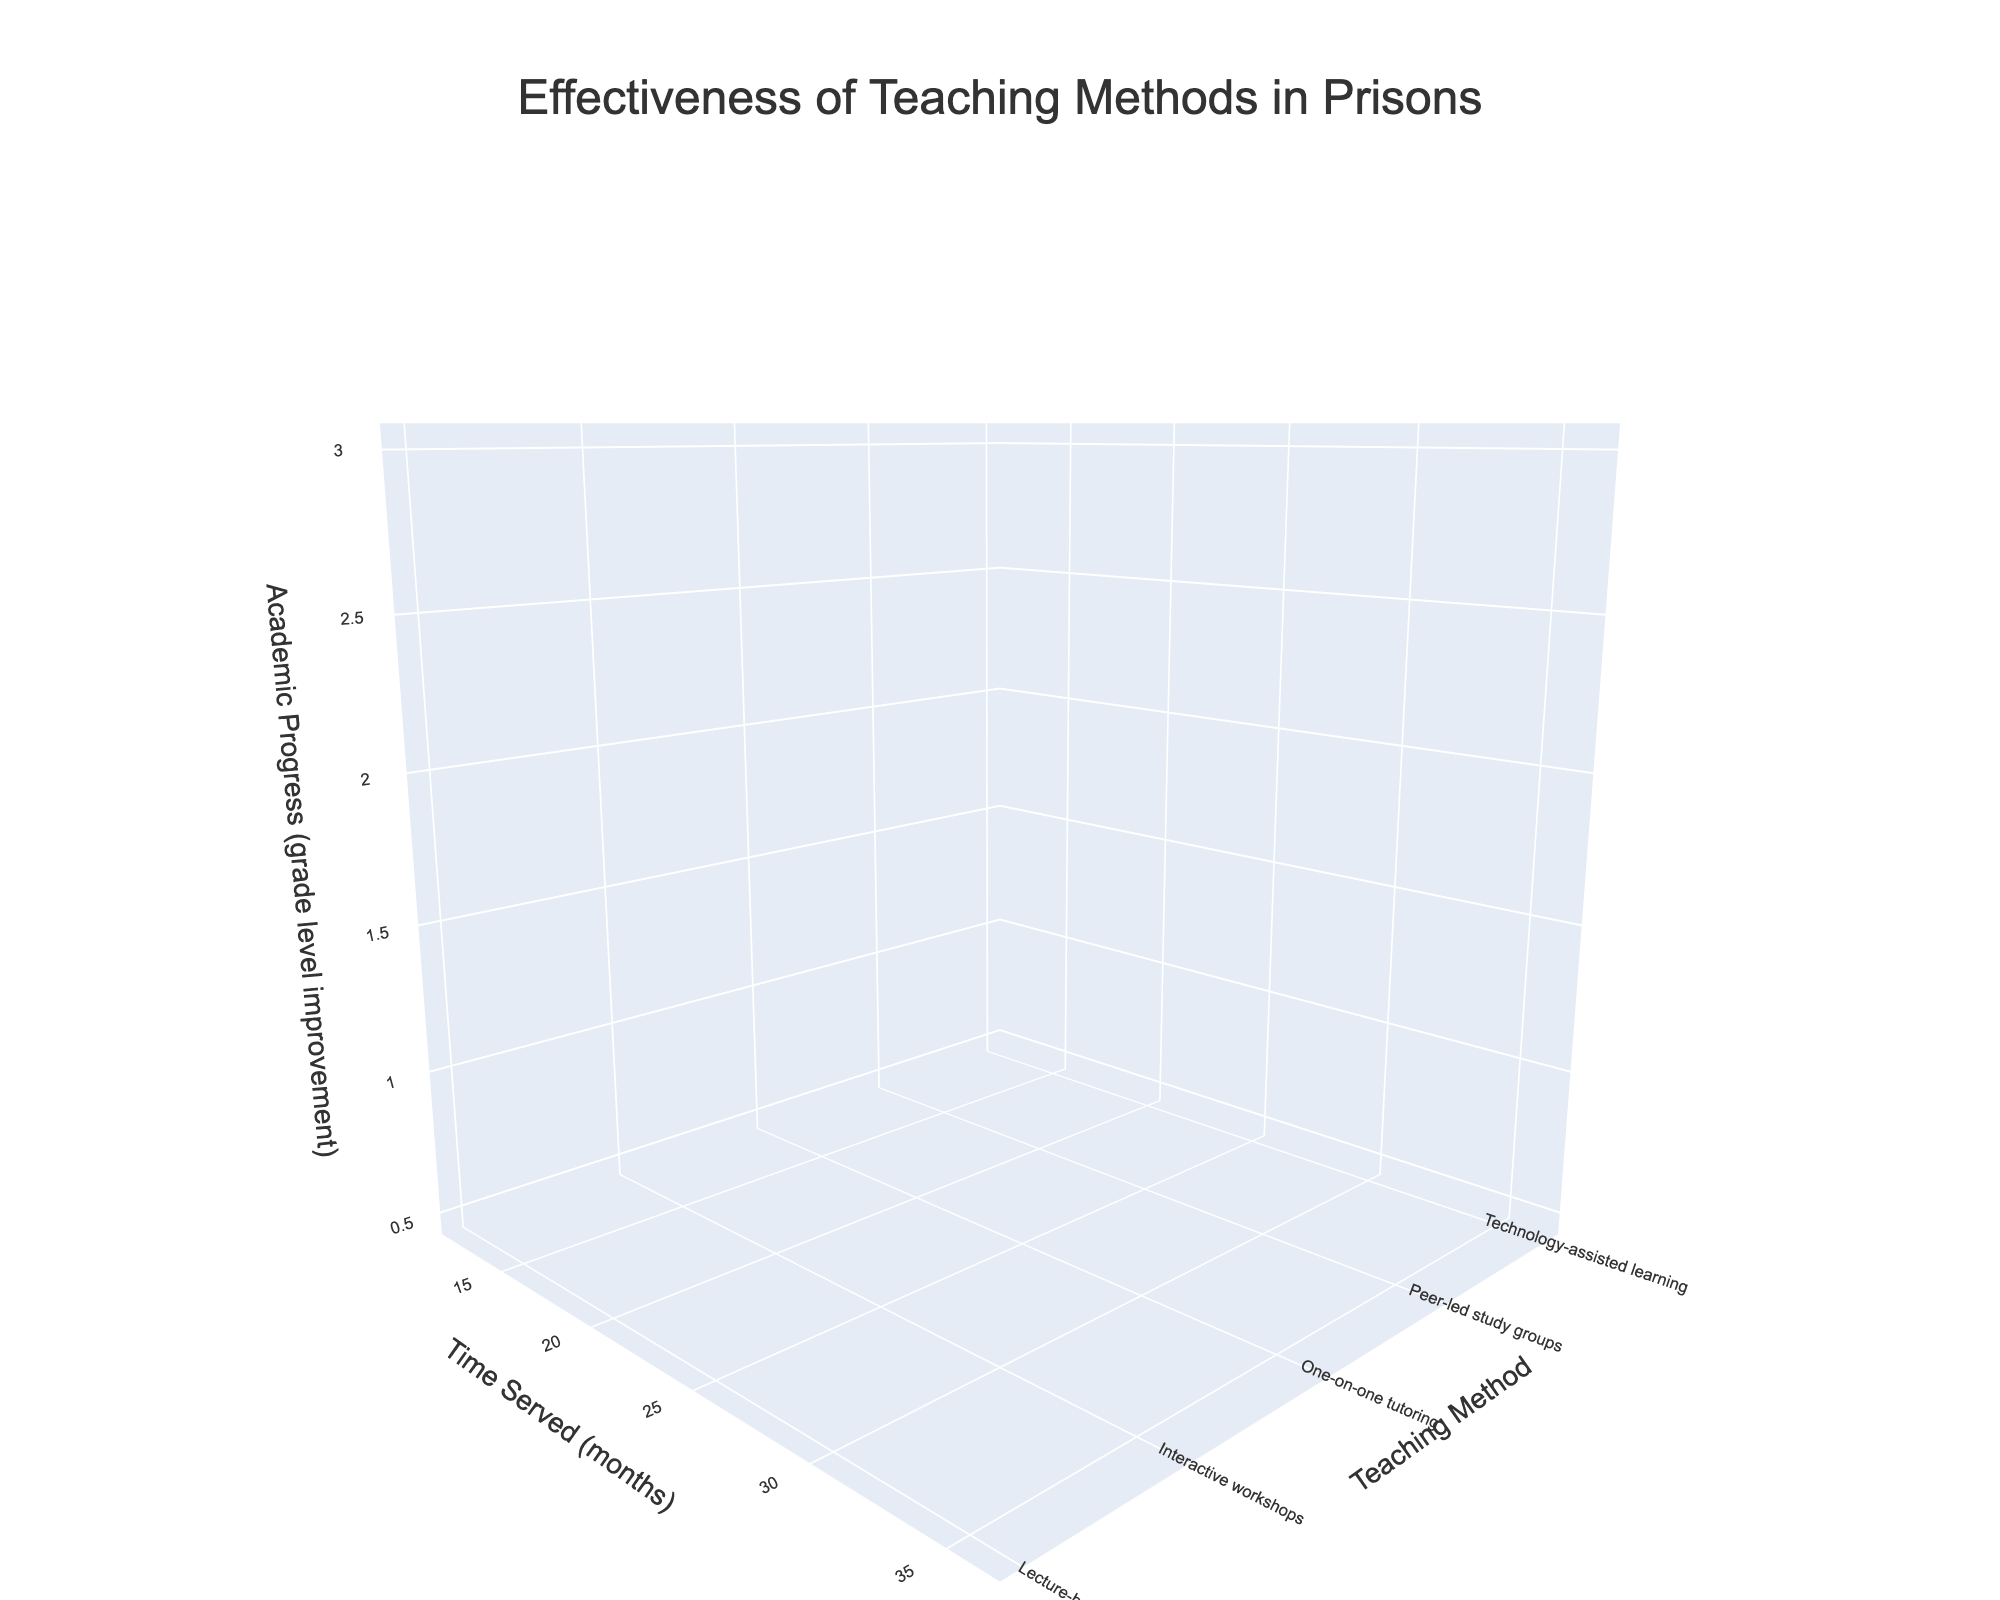What is the title of the figure? The title is located at the top of the plot and is typically the most prominent text. It provides a concise summary of what the figure represents.
Answer: Effectiveness of Teaching Methods in Prisons Which teaching method leads to the highest academic progress after 24 months? By examining the z-axis values (academic progress) for each teaching method at the 24-month mark on the x-axis, you can identify the highest value. One-on-one tutoring shows the highest progress.
Answer: One-on-one tutoring How does the academic progress of lecture-based methods compare with interactive workshops after 12 months? Look at the z-axis values for both lecture-based and interactive workshops at the 12-month point on the x-axis. The lecture-based method has a progress of 0.5, while workshops have 0.8.
Answer: Interactive workshops are higher What is the difference in academic progress between technology-assisted learning and peer-led study groups after 36 months? At the 36-month mark on the x-axis, note the z-axis values for both methods. Technology-assisted learning has a progress of 2.4, and peer-led study groups have 1.8. Subtract the two values to find the difference.
Answer: 0.6 Which teaching method shows the least improvement after 12 months? Identify the z-axis value for academic progress for all methods at the 12-month mark on the x-axis. The method with the lowest value is the one to note. The lecture-based method has the least improvement.
Answer: Lecture-based What is the academic progress improvement for one-on-one tutoring from 12 months to 36 months? To calculate the improvement for one-on-one tutoring, subtract the z-axis value at 12 months (1.2) from the value at 36 months (3.0).
Answer: 1.8 Which teaching method shows the most consistent progress over time? To determine the most consistent progress, assess the z-axis values across all time points (12, 24, 36 months). One-on-one tutoring shows a consistent, steady increase in academic progress.
Answer: One-on-one tutoring How does the color scheme help in distinguishing different teaching methods? Different colors are used for each teaching method. The color palette allows for quick visual identification of trends and comparisons across methods.
Answer: Unique colors for each method What's the overall trend of academic progress across all teaching methods as time served increases? Examine the overall shape of the surface plots; in general, the z-axis values (academic progress) increase as the time served (x-axis) increases for all methods, indicating a positive trend.
Answer: Academic progress increases Which teaching method has the greatest progression between 24 and 36 months? Compare the change in z-axis values from 24 to 36 months for each method. One-on-one tutoring sees the largest increase from 2.2 to 3.0.
Answer: One-on-one tutoring 